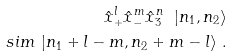Convert formula to latex. <formula><loc_0><loc_0><loc_500><loc_500>{ \hat { x } } ^ { l } _ { + } { \hat { x } } ^ { m } _ { - } { \hat { x } } ^ { n } _ { 3 } \ | n _ { 1 } , n _ { 2 } \rangle \\ s i m \ | n _ { 1 } + l - m , n _ { 2 } + m - l \rangle \ .</formula> 